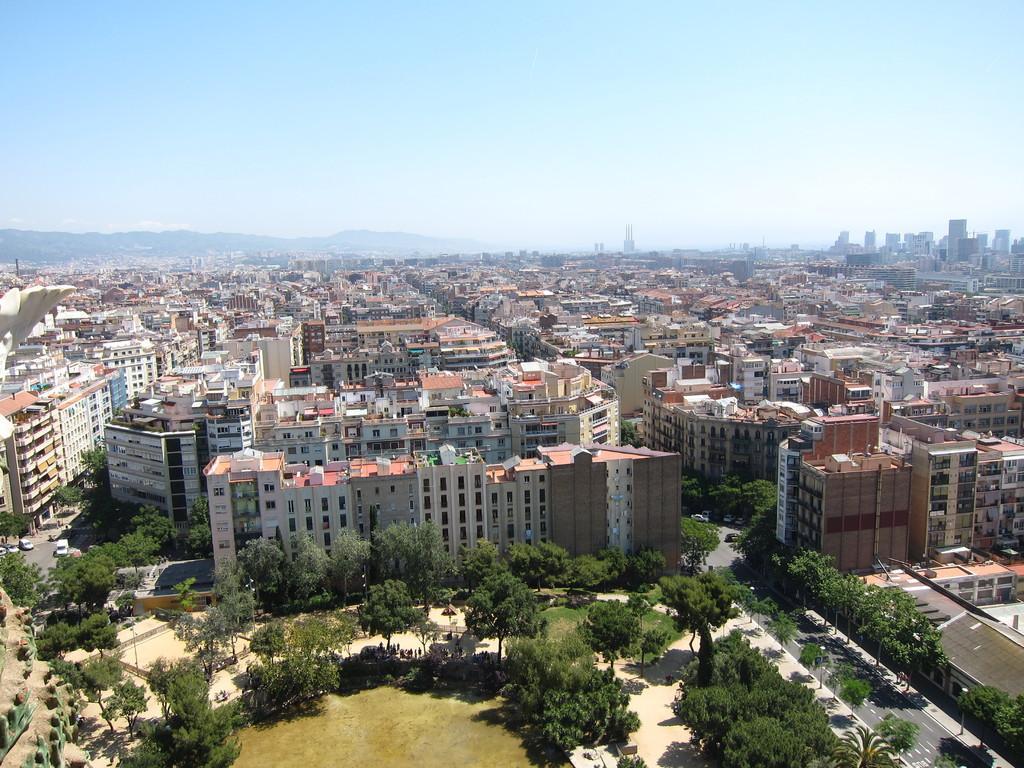Can you describe this image briefly? Here we can see buildings and trees. There are vehicles on the road. In the background we can see sky. 